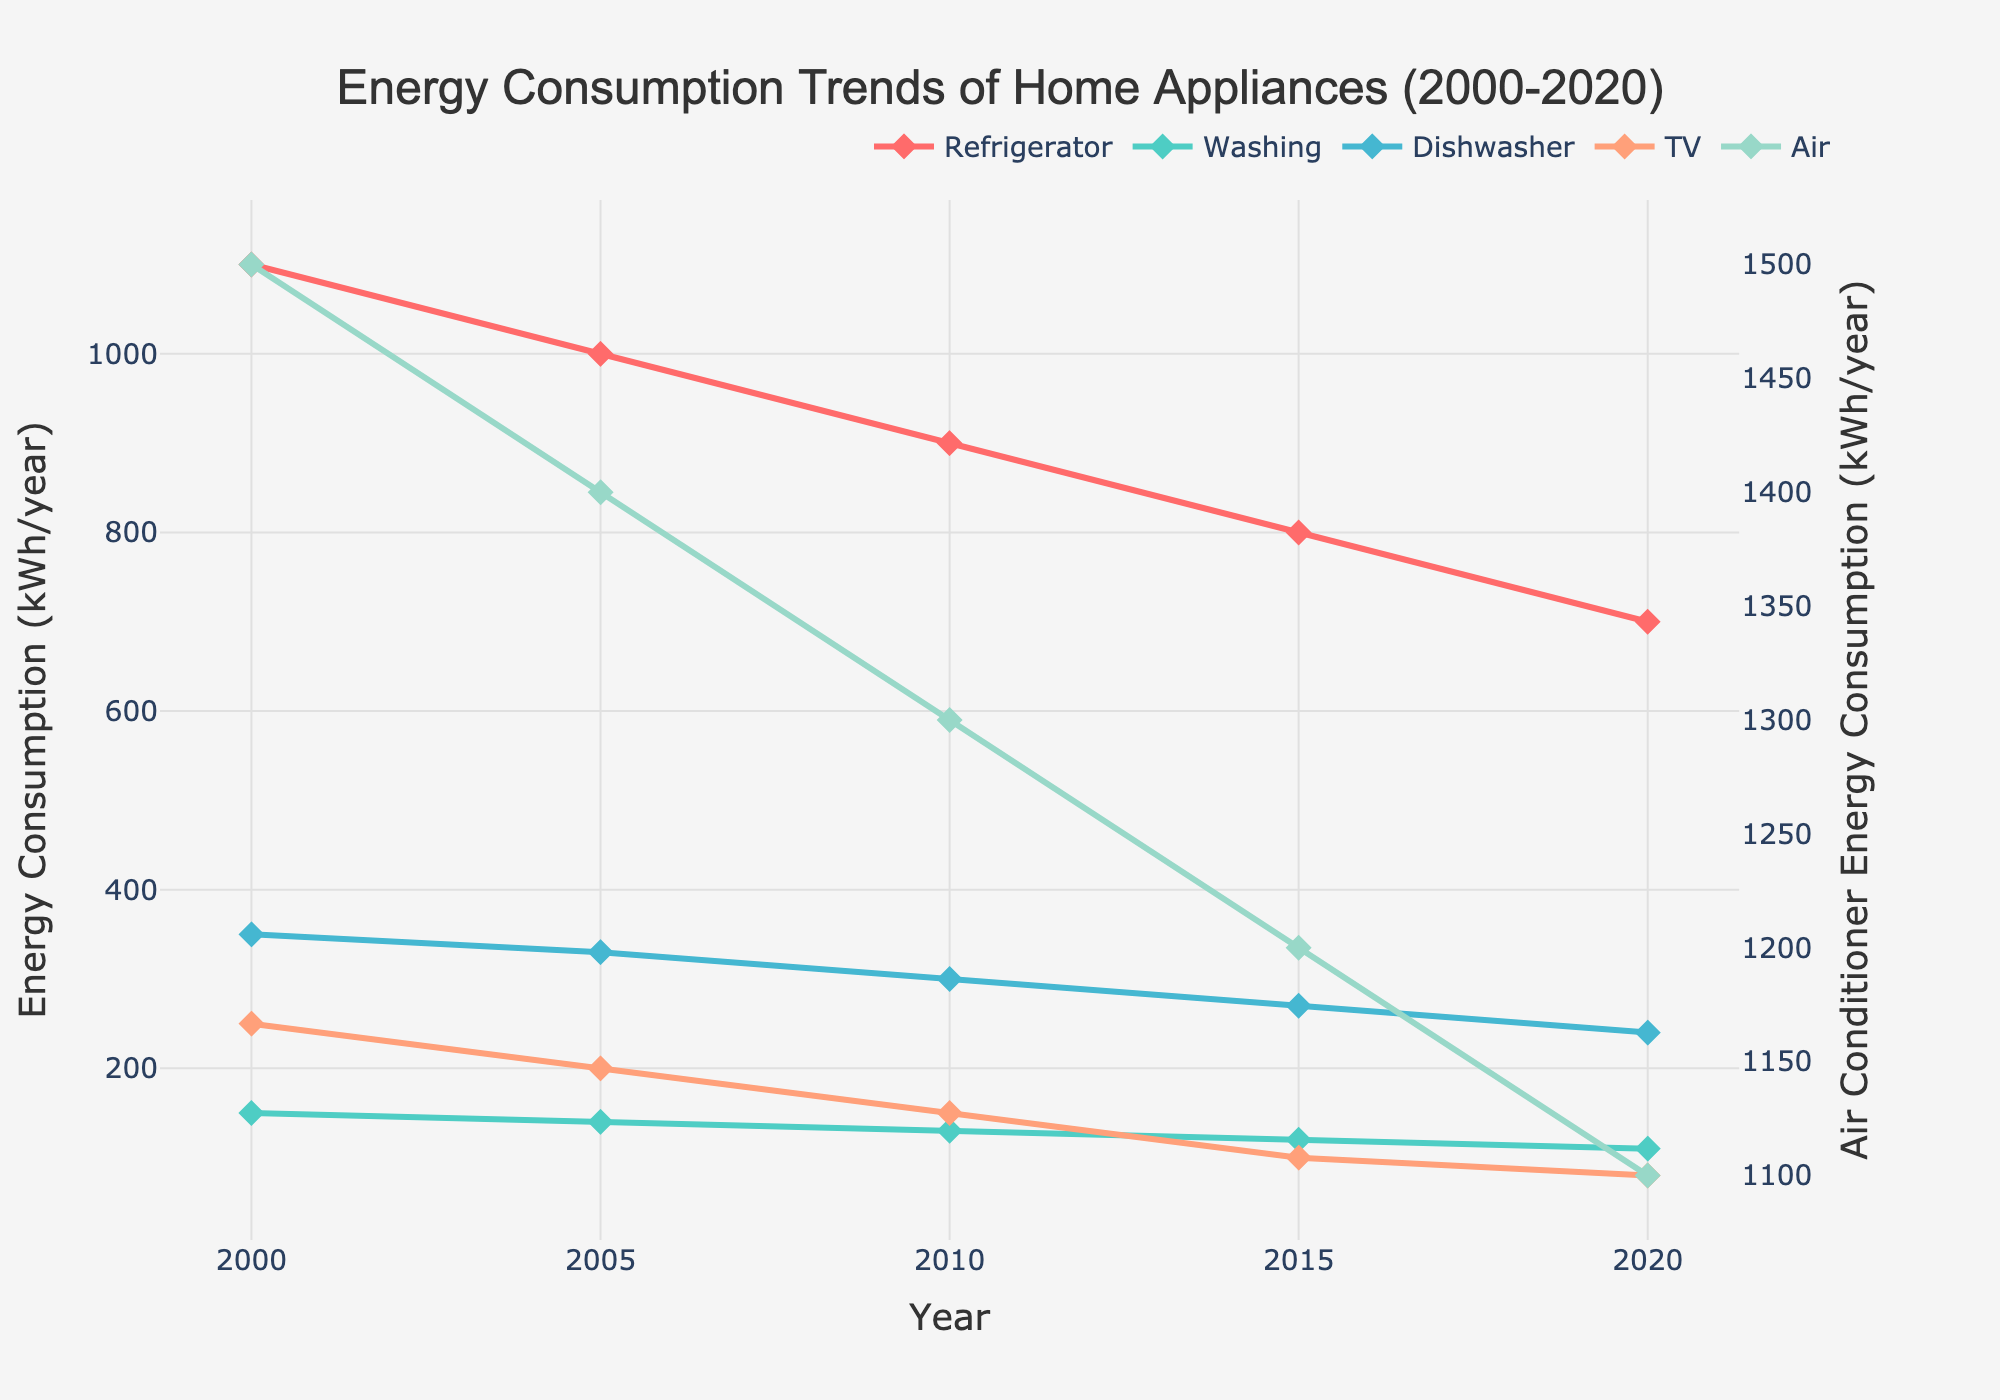What trend can you observe for the energy consumption of refrigerators from 2000 to 2020? The energy consumption of refrigerators shows a consistent decrease from 1100 kWh/year in 2000 to 700 kWh/year in 2020.
Answer: Decreasing Which appliance had the highest energy consumption in 2020? In the figure, the highest line in 2020 corresponds to the Air Conditioner, showing an energy consumption of 1100 kWh/year.
Answer: Air Conditioner How does the energy consumption of the TV and the Washing Machine compare in 2010? In 2010, the TV shows a consumption of 150 kWh/year, while the Washing Machine shows 130 kWh/year. So, the TV consumes 20 kWh/year more than the Washing Machine.
Answer: TV consumes more How much did the energy consumption of the Dishwasher decrease from 2000 to 2020? The Dishwasher's energy consumption decreased from 350 kWh/year in 2000 to 240 kWh/year in 2020. The decrease is 350 - 240 = 110 kWh/year.
Answer: 110 kWh/year Which appliance showed the least reduction in energy consumption over the 20 years? By comparing the start and end points for each appliance, the TV showed the least reduction, changing from 250 kWh/year in 2000 to 80 kWh/year in 2020, a reduction of 170 kWh/year.
Answer: TV What is the total energy consumption for all appliances in 2005? In 2005, summing all the energy consumption values: Refrigerator (1000) + Washing Machine (140) + Dishwasher (330) + TV (200) + Air Conditioner (1400) = 3070 kWh/year.
Answer: 3070 kWh/year Compare the energy consumption of the Air Conditioner to the Dishwasher in 2000. In 2000, the Air Conditioner consumed 1500 kWh/year while the Dishwasher consumed 350 kWh/year. The Air Conditioner consumed 1150 kWh/year more than the Dishwasher.
Answer: Air Conditioner consumes more What is the difference in energy consumption between the Refrigerator and the Washing Machine in 2015? In 2015, the Refrigerator consumed 800 kWh/year while the Washing Machine consumed 120 kWh/year. The difference is 800 - 120 = 680 kWh/year.
Answer: 680 kWh/year Calculate the average energy consumption of the Dishwasher over the 20 years. The energy consumption of the Dishwasher over 5 years is 350, 330, 300, 270, 240. The sum of these values is 1490, and the average is 1490 / 5 = 298 kWh/year.
Answer: 298 kWh/year Which appliance had the most significant reduction in energy consumption from 2000 to 2020? The Refrigerator decreased from 1100 kWh/year in 2000 to 700 kWh/year in 2020, a reduction of 400 kWh/year. This is the most significant reduction among all appliances.
Answer: Refrigerator 